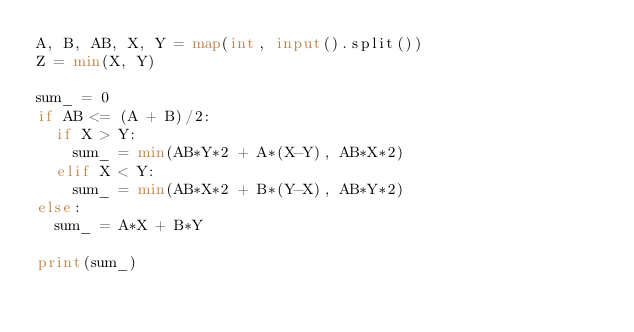<code> <loc_0><loc_0><loc_500><loc_500><_Python_>A, B, AB, X, Y = map(int, input().split())
Z = min(X, Y)

sum_ = 0
if AB <= (A + B)/2:
  if X > Y:
    sum_ = min(AB*Y*2 + A*(X-Y), AB*X*2)
  elif X < Y:
    sum_ = min(AB*X*2 + B*(Y-X), AB*Y*2)
else:
  sum_ = A*X + B*Y

print(sum_)</code> 